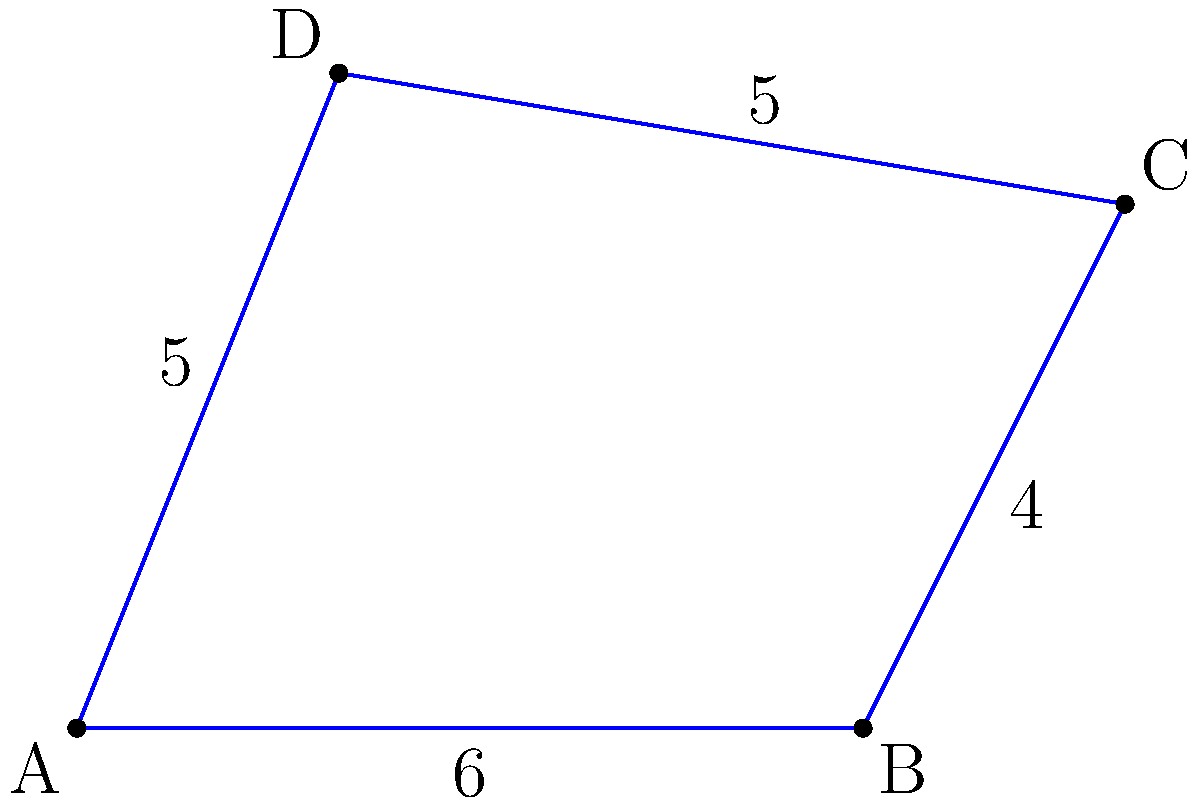In a landscape painting inspired by an iconic film scene, there's an irregularly shaped lake represented by the quadrilateral ABCD. Given that the coordinates of the vertices are A(0,0), B(6,0), C(8,4), and D(2,5), calculate the area of the lake in square units. To find the area of the irregular quadrilateral ABCD, we can use the shoelace formula (also known as the surveyor's formula). The steps are as follows:

1) The shoelace formula for a quadrilateral with vertices $(x_1, y_1)$, $(x_2, y_2)$, $(x_3, y_3)$, and $(x_4, y_4)$ is:

   Area = $\frac{1}{2}|x_1y_2 + x_2y_3 + x_3y_4 + x_4y_1 - y_1x_2 - y_2x_3 - y_3x_4 - y_4x_1|$

2) We have:
   A(0,0), B(6,0), C(8,4), D(2,5)

3) Substituting these coordinates into the formula:

   Area = $\frac{1}{2}|(0 \cdot 0 + 6 \cdot 4 + 8 \cdot 5 + 2 \cdot 0) - (0 \cdot 6 + 0 \cdot 8 + 4 \cdot 2 + 5 \cdot 0)|$

4) Simplifying:
   
   Area = $\frac{1}{2}|(0 + 24 + 40 + 0) - (0 + 0 + 8 + 0)|$
   
   Area = $\frac{1}{2}|64 - 8|$
   
   Area = $\frac{1}{2}(56)$
   
   Area = $28$

Therefore, the area of the lake is 28 square units.
Answer: 28 square units 